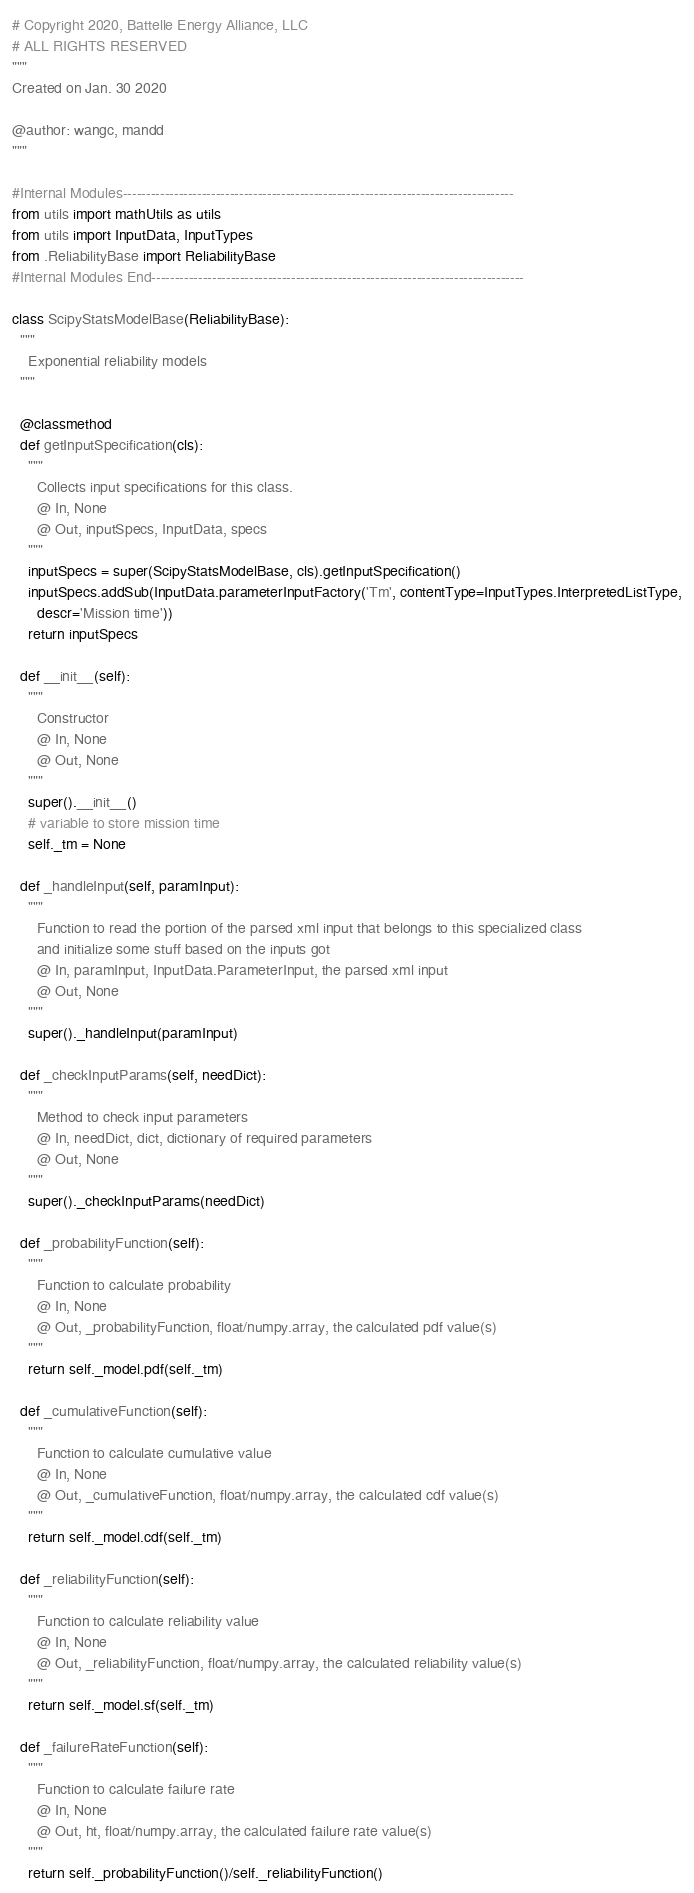<code> <loc_0><loc_0><loc_500><loc_500><_Python_># Copyright 2020, Battelle Energy Alliance, LLC
# ALL RIGHTS RESERVED
"""
Created on Jan. 30 2020

@author: wangc, mandd
"""

#Internal Modules------------------------------------------------------------------------------------
from utils import mathUtils as utils
from utils import InputData, InputTypes
from .ReliabilityBase import ReliabilityBase
#Internal Modules End--------------------------------------------------------------------------------

class ScipyStatsModelBase(ReliabilityBase):
  """
    Exponential reliability models
  """

  @classmethod
  def getInputSpecification(cls):
    """
      Collects input specifications for this class.
      @ In, None
      @ Out, inputSpecs, InputData, specs
    """
    inputSpecs = super(ScipyStatsModelBase, cls).getInputSpecification()
    inputSpecs.addSub(InputData.parameterInputFactory('Tm', contentType=InputTypes.InterpretedListType,
      descr='Mission time'))
    return inputSpecs

  def __init__(self):
    """
      Constructor
      @ In, None
      @ Out, None
    """
    super().__init__()
    # variable to store mission time
    self._tm = None

  def _handleInput(self, paramInput):
    """
      Function to read the portion of the parsed xml input that belongs to this specialized class
      and initialize some stuff based on the inputs got
      @ In, paramInput, InputData.ParameterInput, the parsed xml input
      @ Out, None
    """
    super()._handleInput(paramInput)

  def _checkInputParams(self, needDict):
    """
      Method to check input parameters
      @ In, needDict, dict, dictionary of required parameters
      @ Out, None
    """
    super()._checkInputParams(needDict)

  def _probabilityFunction(self):
    """
      Function to calculate probability
      @ In, None
      @ Out, _probabilityFunction, float/numpy.array, the calculated pdf value(s)
    """
    return self._model.pdf(self._tm)

  def _cumulativeFunction(self):
    """
      Function to calculate cumulative value
      @ In, None
      @ Out, _cumulativeFunction, float/numpy.array, the calculated cdf value(s)
    """
    return self._model.cdf(self._tm)

  def _reliabilityFunction(self):
    """
      Function to calculate reliability value
      @ In, None
      @ Out, _reliabilityFunction, float/numpy.array, the calculated reliability value(s)
    """
    return self._model.sf(self._tm)

  def _failureRateFunction(self):
    """
      Function to calculate failure rate
      @ In, None
      @ Out, ht, float/numpy.array, the calculated failure rate value(s)
    """
    return self._probabilityFunction()/self._reliabilityFunction()
</code> 